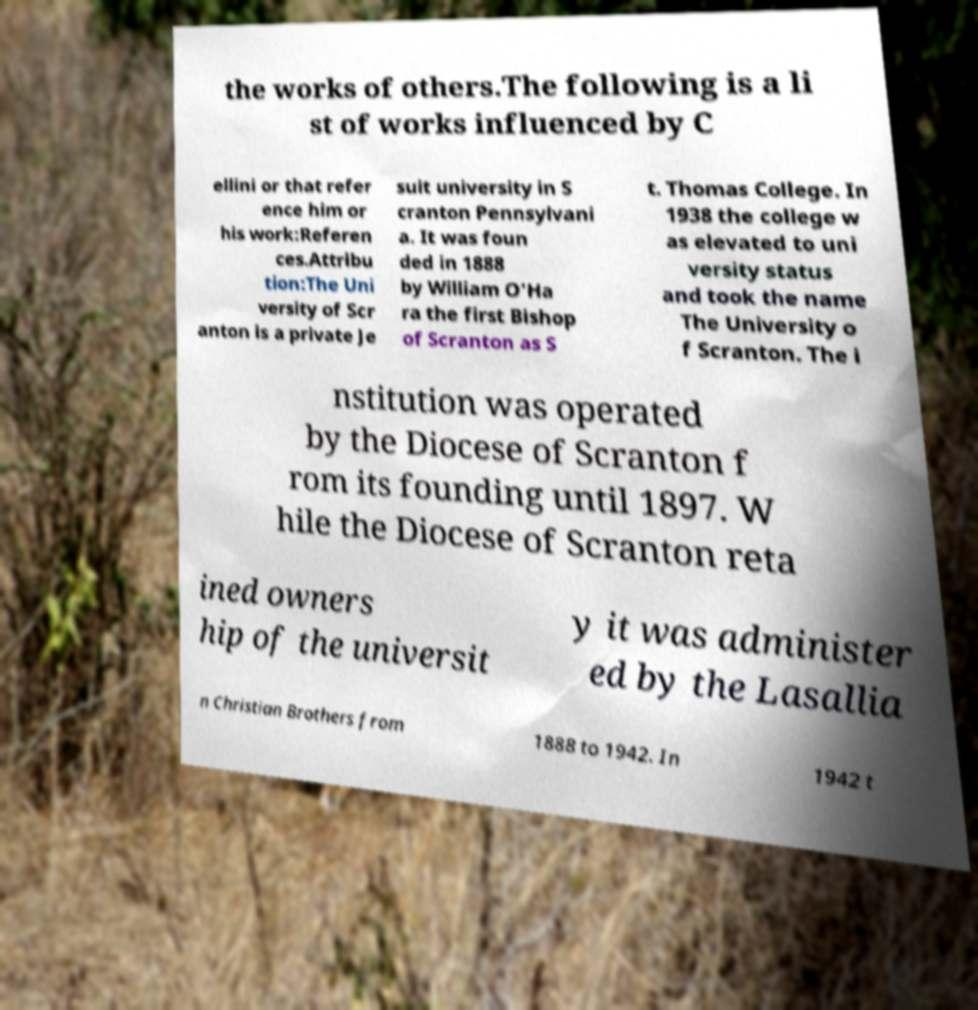I need the written content from this picture converted into text. Can you do that? the works of others.The following is a li st of works influenced by C ellini or that refer ence him or his work:Referen ces.Attribu tion:The Uni versity of Scr anton is a private Je suit university in S cranton Pennsylvani a. It was foun ded in 1888 by William O'Ha ra the first Bishop of Scranton as S t. Thomas College. In 1938 the college w as elevated to uni versity status and took the name The University o f Scranton. The i nstitution was operated by the Diocese of Scranton f rom its founding until 1897. W hile the Diocese of Scranton reta ined owners hip of the universit y it was administer ed by the Lasallia n Christian Brothers from 1888 to 1942. In 1942 t 